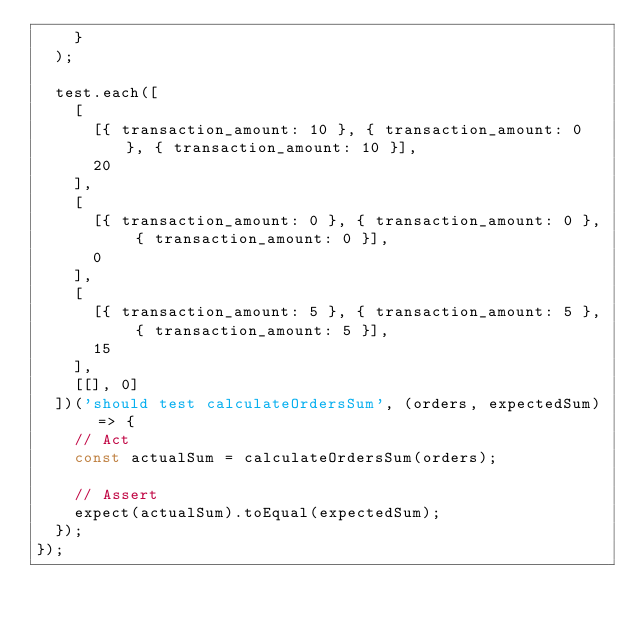<code> <loc_0><loc_0><loc_500><loc_500><_JavaScript_>    }
  );

  test.each([
    [
      [{ transaction_amount: 10 }, { transaction_amount: 0 }, { transaction_amount: 10 }],
      20
    ],
    [
      [{ transaction_amount: 0 }, { transaction_amount: 0 }, { transaction_amount: 0 }],
      0
    ],
    [
      [{ transaction_amount: 5 }, { transaction_amount: 5 }, { transaction_amount: 5 }],
      15
    ],
    [[], 0]
  ])('should test calculateOrdersSum', (orders, expectedSum) => {
    // Act
    const actualSum = calculateOrdersSum(orders);

    // Assert
    expect(actualSum).toEqual(expectedSum);
  });
});
</code> 